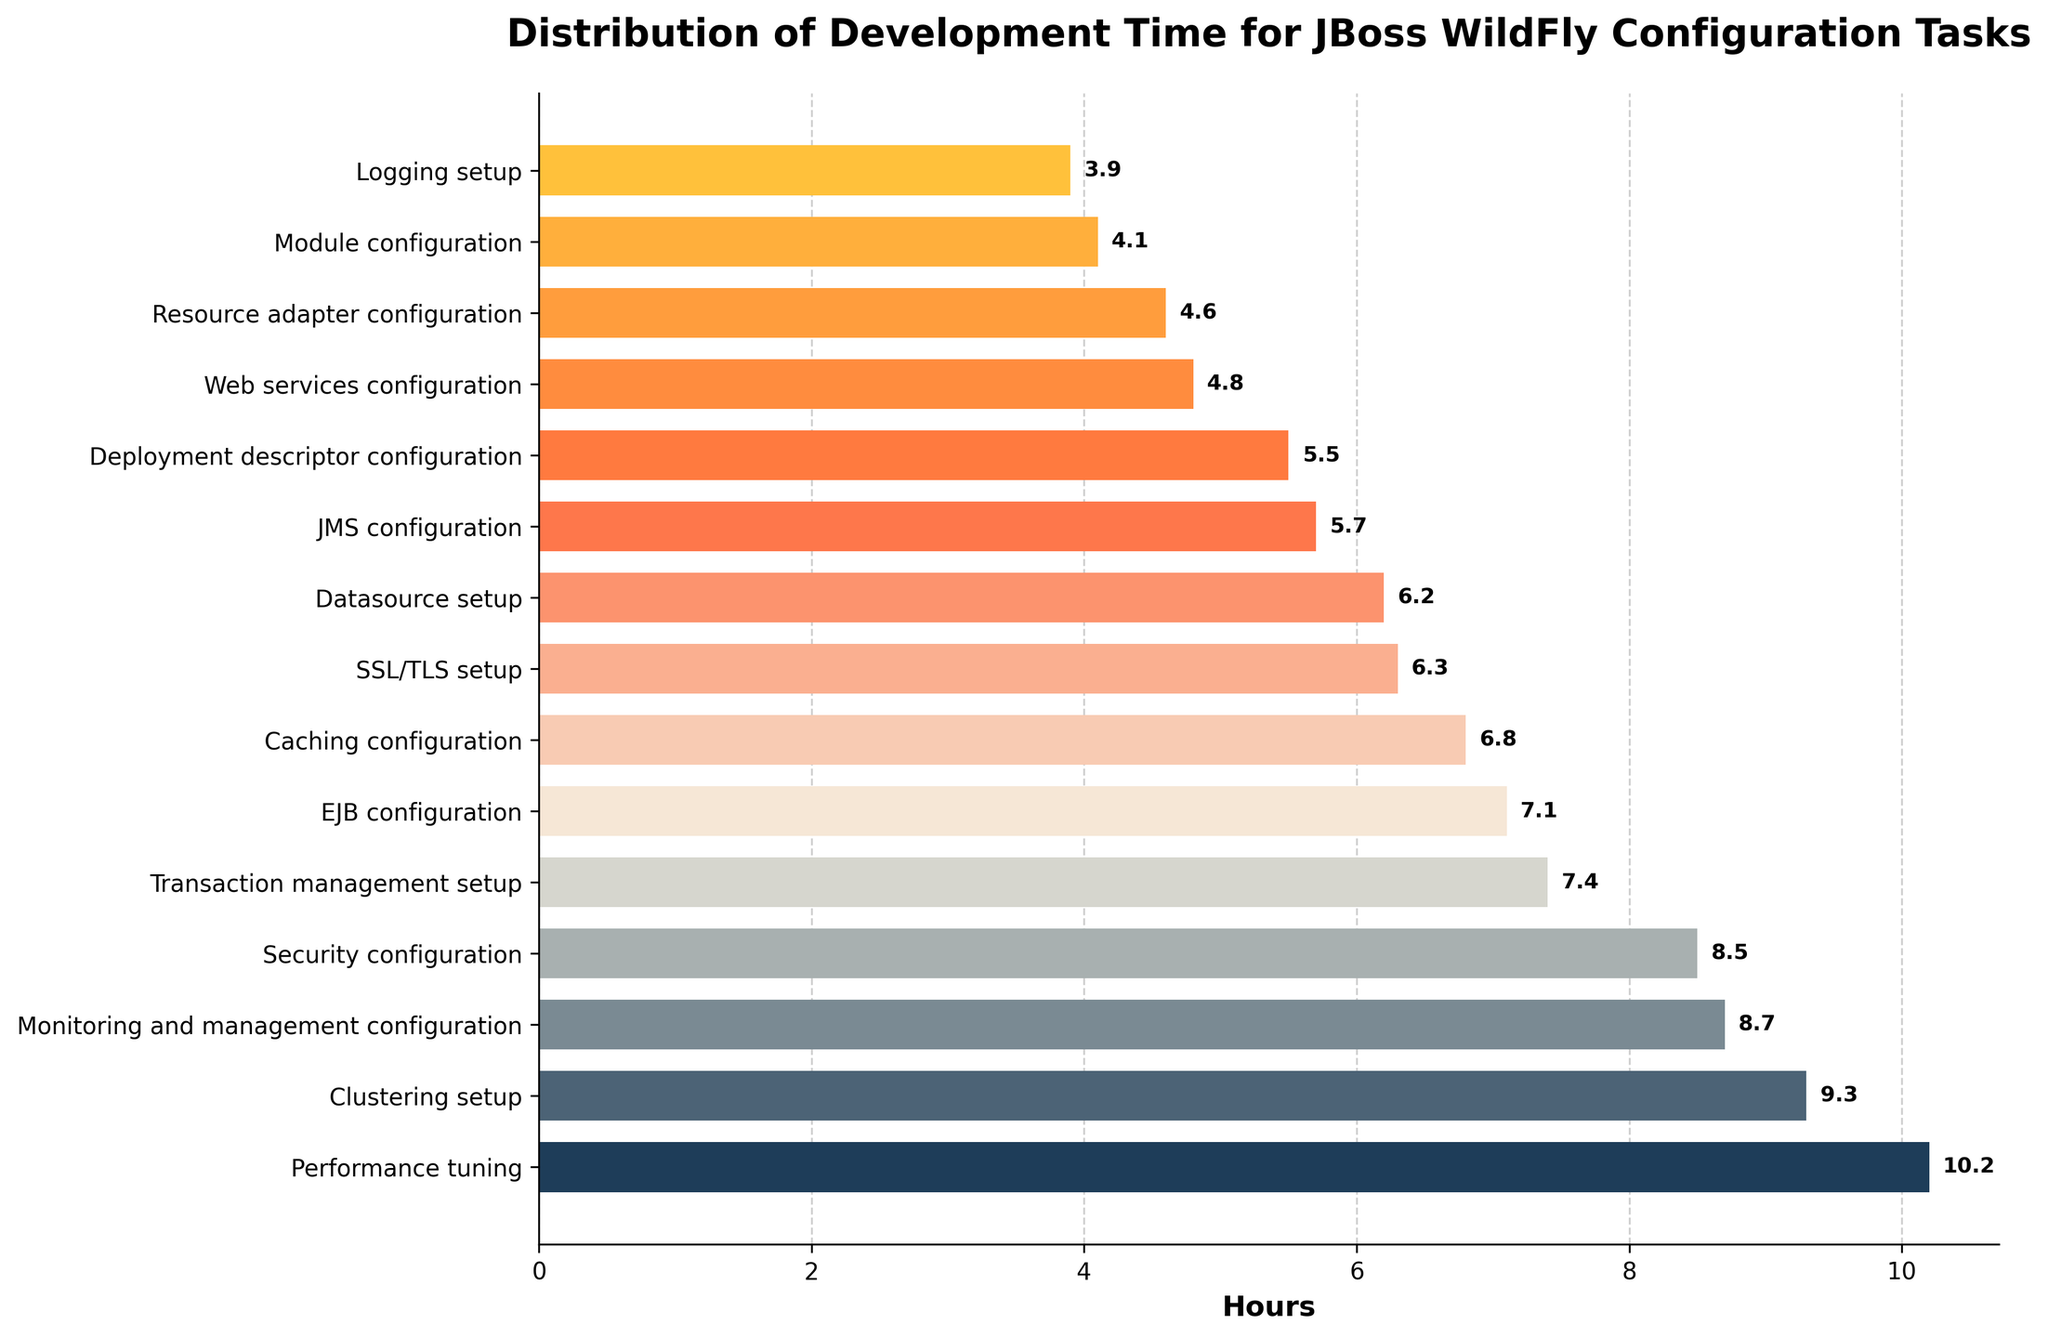What's the title of the plot? Look at the top of the plot where the title text is displayed. The plot's title is in bold and reads: "Distribution of Development Time for JBoss WildFly Configuration Tasks."
Answer: Distribution of Development Time for JBoss WildFly Configuration Tasks Which task takes the most amount of time? Look at the highest bar on the horizontal density plot. The bar at the top of the plot corresponds to the "Clustering setup" task, which has the highest value.
Answer: Clustering setup What is the range of the time spent on different tasks? Identify the minimum and maximum values from the bars. The shortest bar is "Logging setup" with 3.9 hours, and the longest bar is "Performance tuning" with 10.2 hours. Calculate the range by subtracting the minimum from the maximum. 10.2 - 3.9 = 6.3 hours.
Answer: 6.3 hours Which task category takes more time, 'Security configuration' or 'Monitoring and management configuration'? Compare the lengths of the bars corresponding to these tasks. "Security configuration" takes 8.5 hours, and "Monitoring and management configuration" takes 8.7 hours. Since 8.7 is greater than 8.5, "Monitoring and management configuration" takes more time.
Answer: Monitoring and management configuration What is the average time spent on tasks that take more than 7 hours? Identify tasks with time more than 7 hours: "Security configuration" (8.5), "Clustering setup" (9.3), "Performance tuning" (10.2), "EJB configuration" (7.1), "Transaction management setup" (7.4), "Monitoring and management configuration" (8.7). Sum these values and divide by the number of entries: (8.5 + 9.3 + 10.2 + 7.1 + 7.4 + 8.7) / 6 = 51.2 / 6 = 8.53 hours.
Answer: 8.53 hours How many tasks take less than 5 hours to complete? Count the bars with a length less than 5. These tasks are "Logging setup" (3.9), "Web services configuration" (4.8), "Resource adapter configuration" (4.6), and "Module configuration" (4.1). There are 4 tasks.
Answer: 4 tasks What is the difference in hours between the time spent on 'Datasource setup' and 'SSL/TLS setup'? Look at the bars for "Datasource setup" and "SSL/TLS setup". "Datasource setup" takes 6.2 hours, and "SSL/TLS setup" takes 6.3 hours. Subtract the smaller value from the larger value: 6.3 - 6.2 = 0.1 hours.
Answer: 0.1 hours Which task spends a median amount of time? To find the median, list the hours in order: 3.9, 4.1, 4.6, 4.8, 5.5, 5.7, 6.2, 6.3, 6.8, 7.1, 7.4, 8.5, 8.7, 9.3, 10.2. The median is the middle value, which is "SSL/TLS setup" with 6.3 hours.
Answer: SSL/TLS setup 